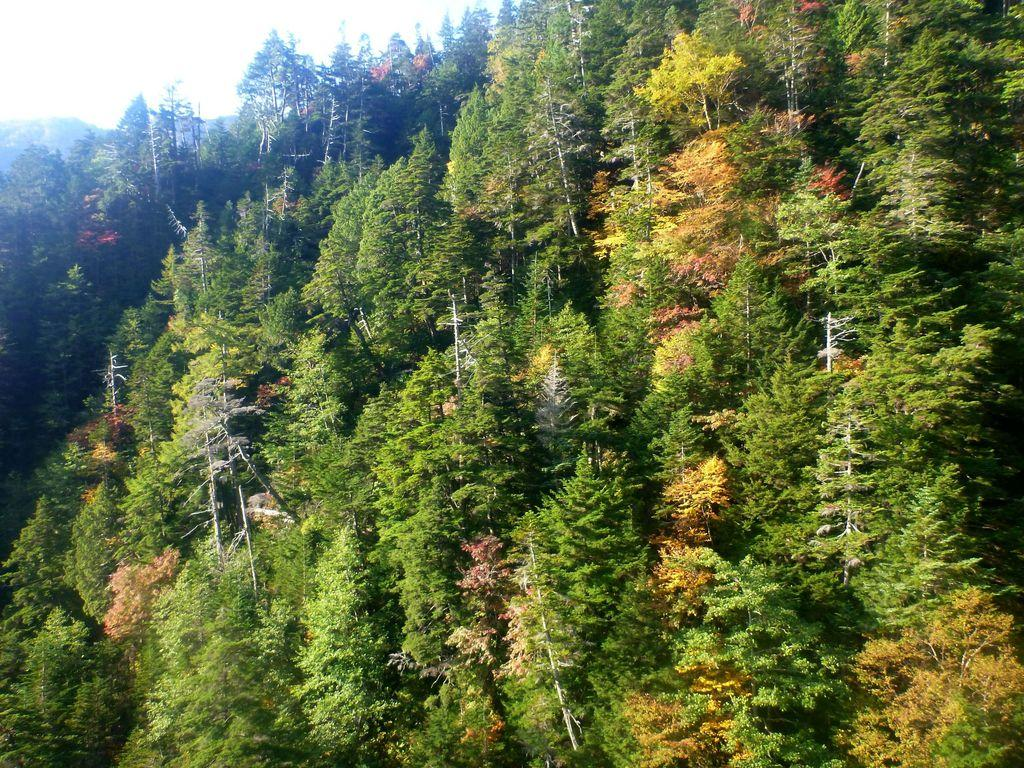What type of vegetation can be seen in the image? There are trees in the image. What colors are the trees in the image? The trees have various colors, including green, white, pink, and yellow. What is visible in the background of the image? There is a mountain and the sky visible in the background of the image. How many toes can be seen on the guitar in the image? There is no guitar present in the image, so it is not possible to determine the number of toes on a guitar. 